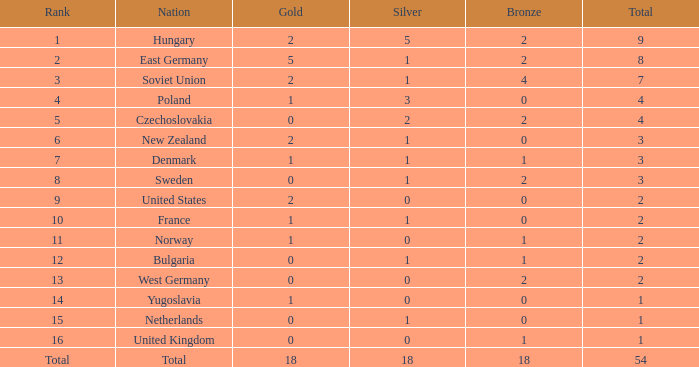What is the least possible sum for people with a total greater than 14 but under 18? 1.0. 